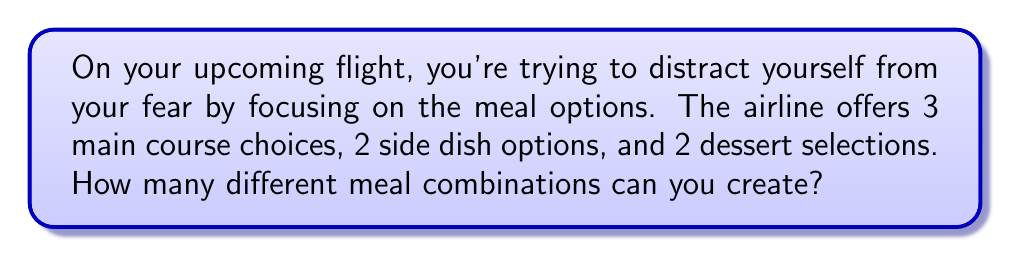Teach me how to tackle this problem. Let's break this down step-by-step:

1) We have three separate categories to choose from:
   - Main course: 3 choices
   - Side dish: 2 choices
   - Dessert: 2 choices

2) For each meal, we need to select one option from each category.

3) This scenario follows the multiplication principle of counting. When we have to make multiple independent choices, we multiply the number of options for each choice.

4) Therefore, the total number of possible meal combinations is:

   $$ 3 \times 2 \times 2 = 12 $$

5) We can also express this using the fundamental counting principle:

   $$ \text{Total combinations} = \text{(Main course options)} \times \text{(Side dish options)} \times \text{(Dessert options)} $$
   $$ = 3 \times 2 \times 2 = 12 $$

This means you have 12 different ways to combine your meal choices, giving you plenty of options to consider and helping keep your mind occupied during the flight.
Answer: 12 combinations 